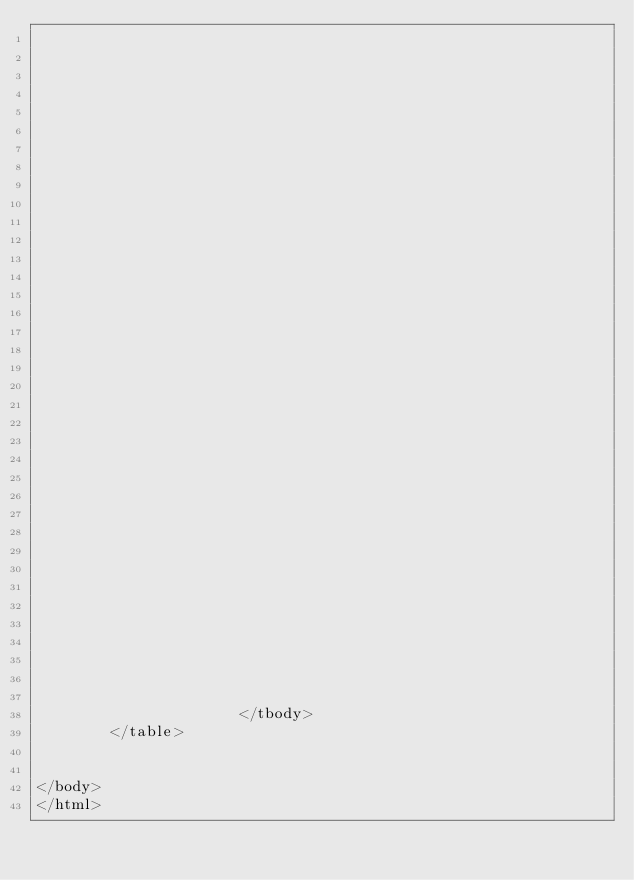Convert code to text. <code><loc_0><loc_0><loc_500><loc_500><_HTML_>
                          

                          

                          

                          

                          

                          

                          

                          

                          

                          

                          

                          

                          

                          

                          

                          

                          

                          

                      </tbody>
        </table>
          

</body>
</html>
</code> 